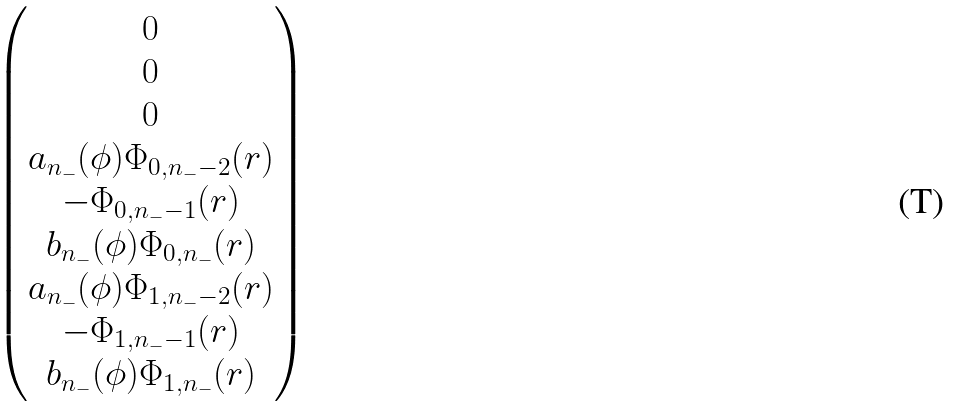<formula> <loc_0><loc_0><loc_500><loc_500>\begin{pmatrix} 0 \\ 0 \\ 0 \\ a _ { n _ { - } } ( \phi ) \Phi _ { 0 , n _ { - } - 2 } ( { r } ) \\ - \Phi _ { 0 , n _ { - } - 1 } ( { r } ) \\ b _ { n _ { - } } ( \phi ) \Phi _ { 0 , n _ { - } } ( { r } ) \\ a _ { n _ { - } } ( \phi ) \Phi _ { 1 , n _ { - } - 2 } ( { r } ) \\ - \Phi _ { 1 , n _ { - } - 1 } ( { r } ) \\ b _ { n _ { - } } ( \phi ) \Phi _ { 1 , n _ { - } } ( { r } ) \\ \end{pmatrix}</formula> 